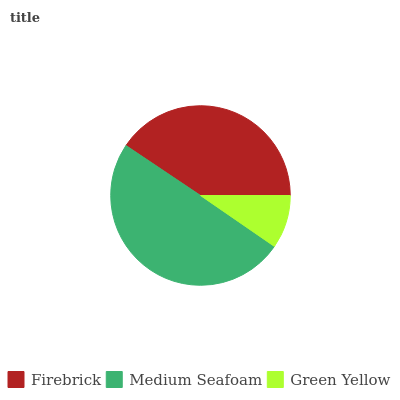Is Green Yellow the minimum?
Answer yes or no. Yes. Is Medium Seafoam the maximum?
Answer yes or no. Yes. Is Medium Seafoam the minimum?
Answer yes or no. No. Is Green Yellow the maximum?
Answer yes or no. No. Is Medium Seafoam greater than Green Yellow?
Answer yes or no. Yes. Is Green Yellow less than Medium Seafoam?
Answer yes or no. Yes. Is Green Yellow greater than Medium Seafoam?
Answer yes or no. No. Is Medium Seafoam less than Green Yellow?
Answer yes or no. No. Is Firebrick the high median?
Answer yes or no. Yes. Is Firebrick the low median?
Answer yes or no. Yes. Is Medium Seafoam the high median?
Answer yes or no. No. Is Medium Seafoam the low median?
Answer yes or no. No. 